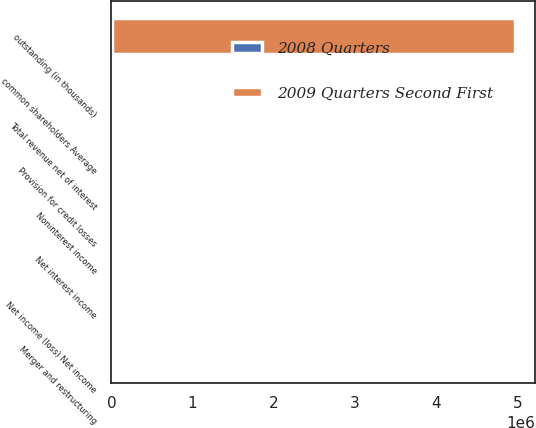<chart> <loc_0><loc_0><loc_500><loc_500><stacked_bar_chart><ecel><fcel>Net interest income<fcel>Noninterest income<fcel>Total revenue net of interest<fcel>Provision for credit losses<fcel>Merger and restructuring<fcel>Net income (loss) Net income<fcel>common shareholders Average<fcel>outstanding (in thousands)<nl><fcel>2008 Quarters<fcel>11559<fcel>13517<fcel>25076<fcel>10110<fcel>533<fcel>194<fcel>5196<fcel>8535<nl><fcel>2009 Quarters Second First<fcel>13106<fcel>2574<fcel>15680<fcel>8535<fcel>306<fcel>1789<fcel>2392<fcel>4.95705e+06<nl></chart> 